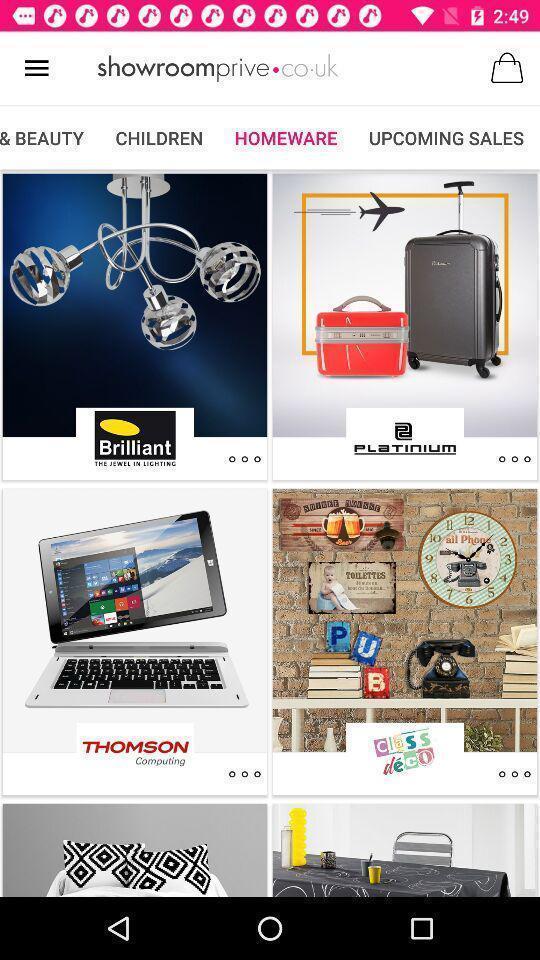What can you discern from this picture? Page of an online shopping application. 